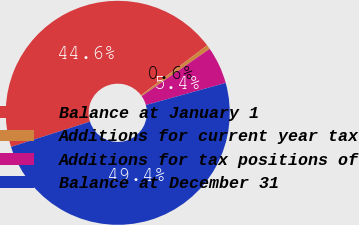Convert chart. <chart><loc_0><loc_0><loc_500><loc_500><pie_chart><fcel>Balance at January 1<fcel>Additions for current year tax<fcel>Additions for tax positions of<fcel>Balance at December 31<nl><fcel>44.62%<fcel>0.62%<fcel>5.38%<fcel>49.38%<nl></chart> 